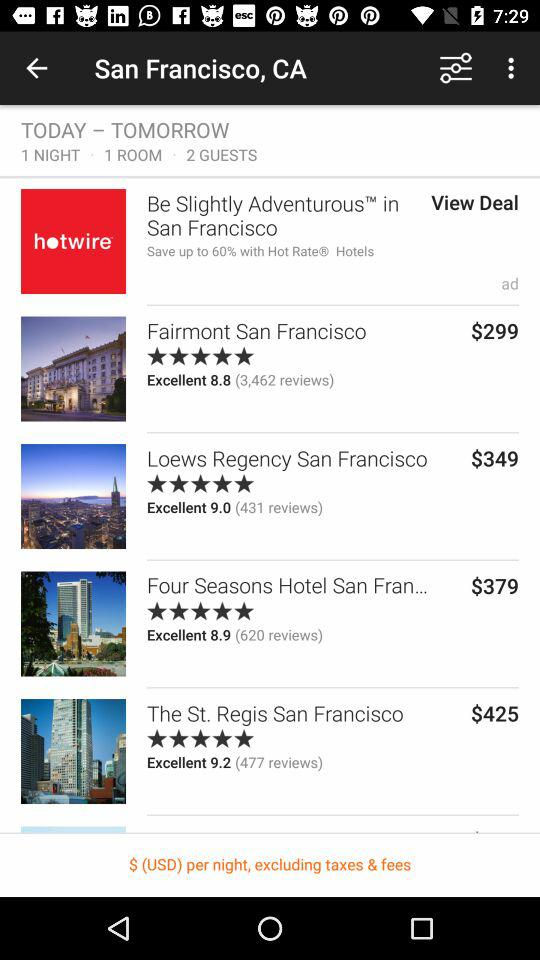What is the booking cost of "Fairmont San Francisco"? The booking cost is $299. 